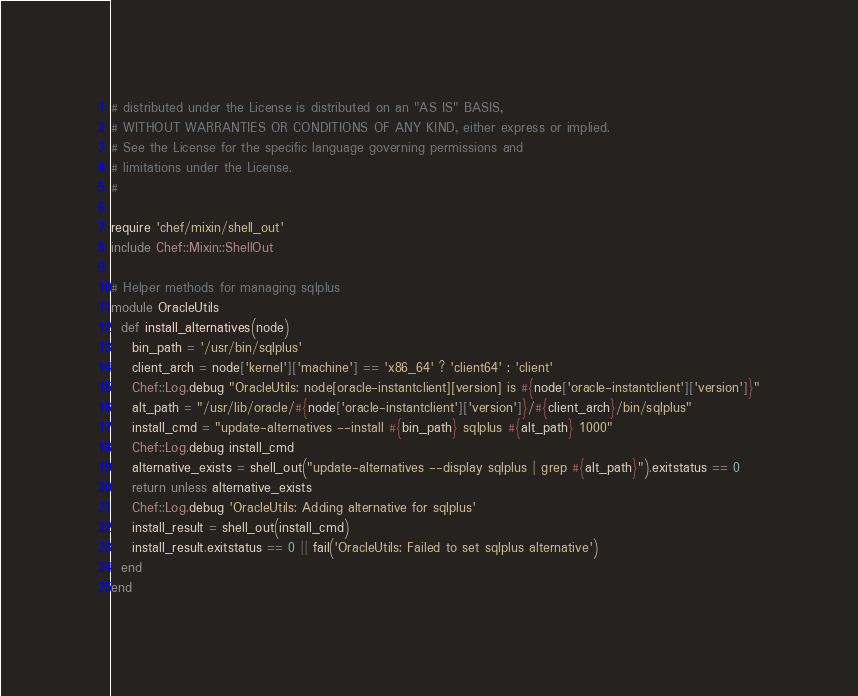Convert code to text. <code><loc_0><loc_0><loc_500><loc_500><_Ruby_># distributed under the License is distributed on an "AS IS" BASIS,
# WITHOUT WARRANTIES OR CONDITIONS OF ANY KIND, either express or implied.
# See the License for the specific language governing permissions and
# limitations under the License.
#

require 'chef/mixin/shell_out'
include Chef::Mixin::ShellOut

# Helper methods for managing sqlplus
module OracleUtils
  def install_alternatives(node)
    bin_path = '/usr/bin/sqlplus'
    client_arch = node['kernel']['machine'] == 'x86_64' ? 'client64' : 'client'
    Chef::Log.debug "OracleUtils: node[oracle-instantclient][version] is #{node['oracle-instantclient']['version']}"
    alt_path = "/usr/lib/oracle/#{node['oracle-instantclient']['version']}/#{client_arch}/bin/sqlplus"
    install_cmd = "update-alternatives --install #{bin_path} sqlplus #{alt_path} 1000"
    Chef::Log.debug install_cmd
    alternative_exists = shell_out("update-alternatives --display sqlplus | grep #{alt_path}").exitstatus == 0
    return unless alternative_exists
    Chef::Log.debug 'OracleUtils: Adding alternative for sqlplus'
    install_result = shell_out(install_cmd)
    install_result.exitstatus == 0 || fail('OracleUtils: Failed to set sqlplus alternative')
  end
end
</code> 